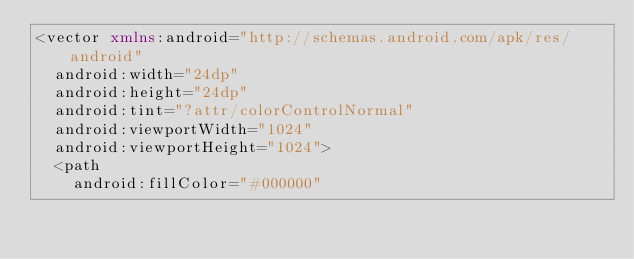Convert code to text. <code><loc_0><loc_0><loc_500><loc_500><_XML_><vector xmlns:android="http://schemas.android.com/apk/res/android"
  android:width="24dp"
  android:height="24dp"
  android:tint="?attr/colorControlNormal"
  android:viewportWidth="1024"
  android:viewportHeight="1024">
  <path
    android:fillColor="#000000"</code> 